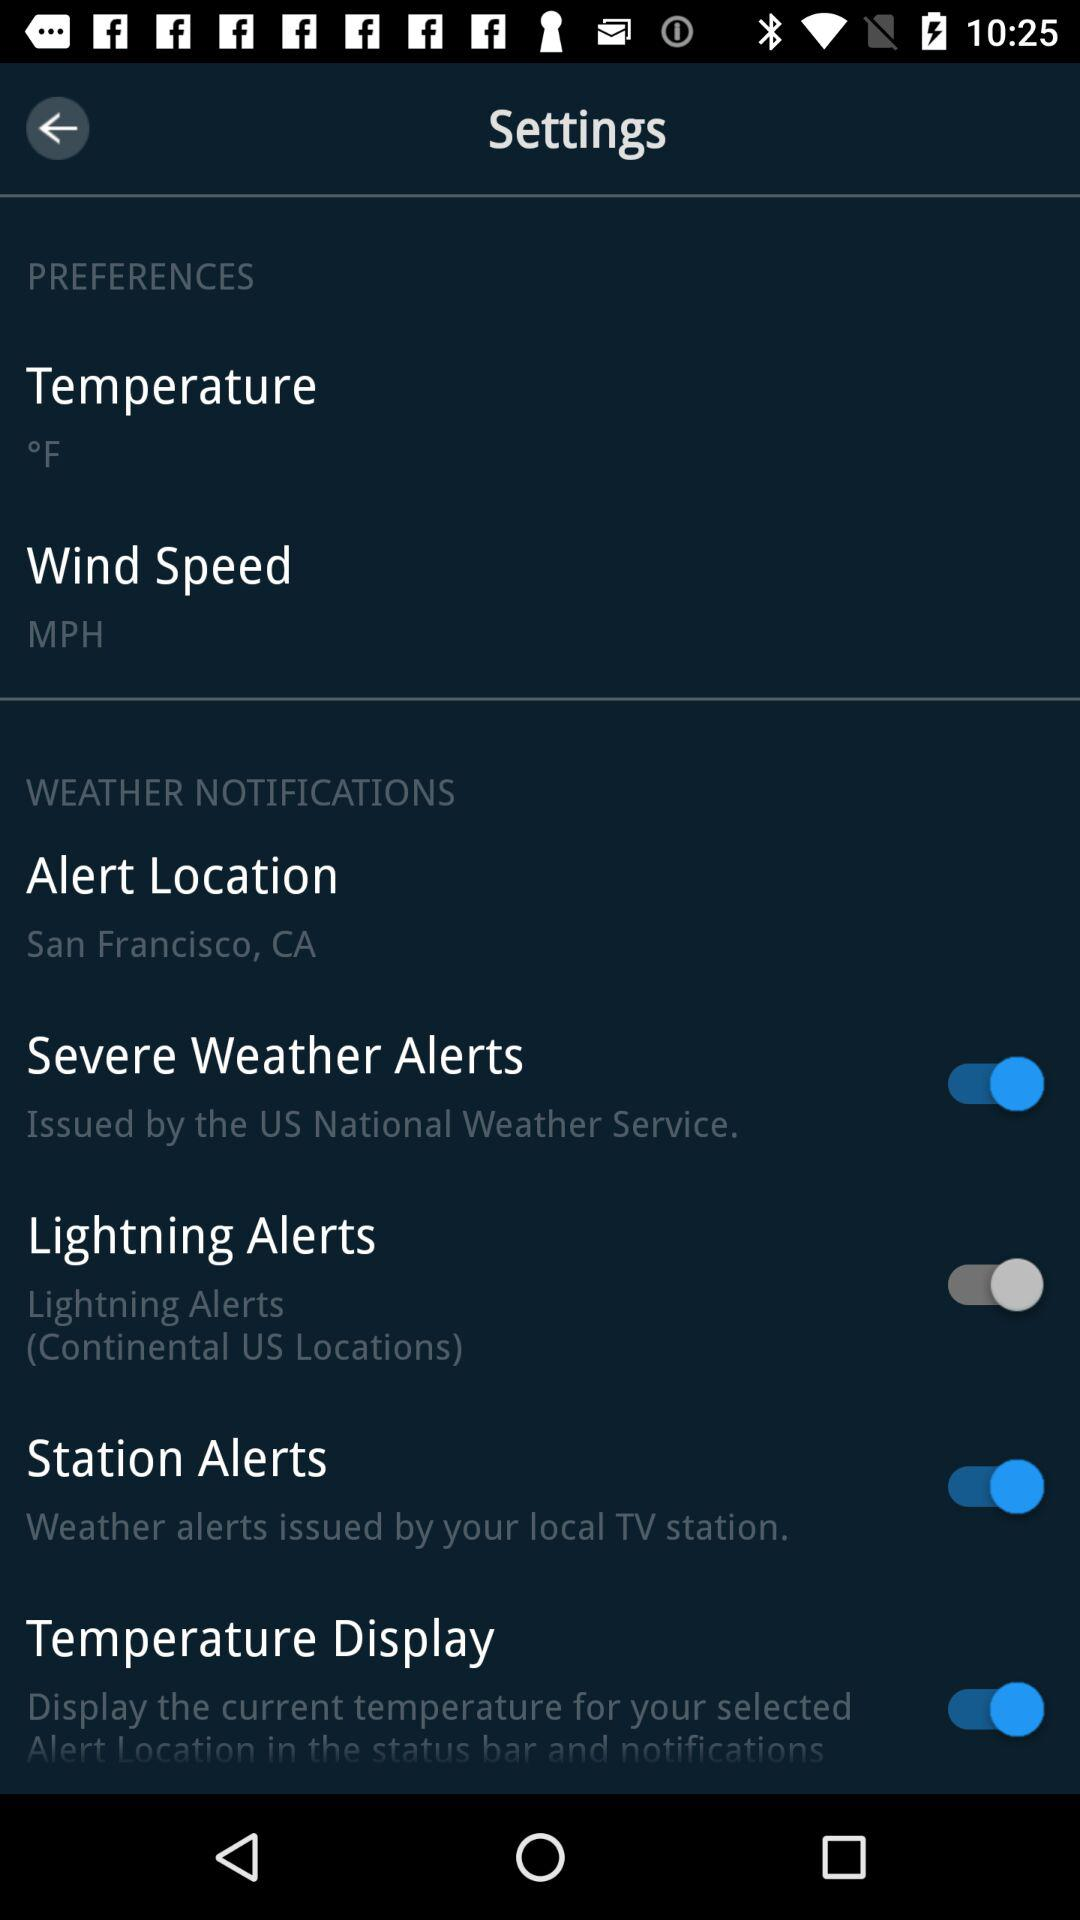How many more items are in the Weather Notifications section than the Preferences section?
Answer the question using a single word or phrase. 3 